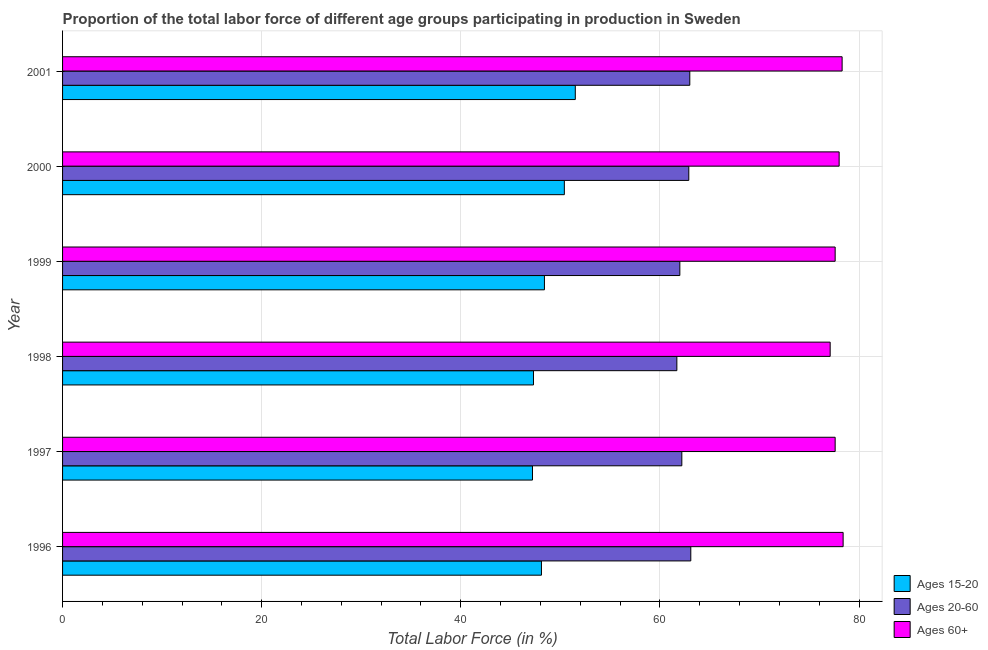How many different coloured bars are there?
Make the answer very short. 3. How many bars are there on the 3rd tick from the bottom?
Ensure brevity in your answer.  3. Across all years, what is the maximum percentage of labor force within the age group 15-20?
Your answer should be very brief. 51.5. Across all years, what is the minimum percentage of labor force above age 60?
Ensure brevity in your answer.  77.1. In which year was the percentage of labor force within the age group 20-60 maximum?
Offer a terse response. 1996. What is the total percentage of labor force within the age group 20-60 in the graph?
Keep it short and to the point. 374.9. What is the difference between the percentage of labor force above age 60 in 1997 and the percentage of labor force within the age group 15-20 in 1999?
Your response must be concise. 29.2. What is the average percentage of labor force within the age group 20-60 per year?
Give a very brief answer. 62.48. In the year 2000, what is the difference between the percentage of labor force above age 60 and percentage of labor force within the age group 15-20?
Your answer should be very brief. 27.6. What is the ratio of the percentage of labor force above age 60 in 1997 to that in 1999?
Make the answer very short. 1. Is the percentage of labor force within the age group 20-60 in 1999 less than that in 2001?
Give a very brief answer. Yes. Is the difference between the percentage of labor force within the age group 20-60 in 1998 and 1999 greater than the difference between the percentage of labor force within the age group 15-20 in 1998 and 1999?
Your response must be concise. Yes. What is the difference between the highest and the second highest percentage of labor force above age 60?
Provide a succinct answer. 0.1. What is the difference between the highest and the lowest percentage of labor force above age 60?
Your response must be concise. 1.3. What does the 3rd bar from the top in 2000 represents?
Keep it short and to the point. Ages 15-20. What does the 1st bar from the bottom in 1998 represents?
Offer a terse response. Ages 15-20. Is it the case that in every year, the sum of the percentage of labor force within the age group 15-20 and percentage of labor force within the age group 20-60 is greater than the percentage of labor force above age 60?
Offer a terse response. Yes. Are all the bars in the graph horizontal?
Provide a succinct answer. Yes. Does the graph contain grids?
Give a very brief answer. Yes. What is the title of the graph?
Provide a succinct answer. Proportion of the total labor force of different age groups participating in production in Sweden. What is the label or title of the Y-axis?
Offer a very short reply. Year. What is the Total Labor Force (in %) in Ages 15-20 in 1996?
Your response must be concise. 48.1. What is the Total Labor Force (in %) in Ages 20-60 in 1996?
Provide a succinct answer. 63.1. What is the Total Labor Force (in %) of Ages 60+ in 1996?
Provide a short and direct response. 78.4. What is the Total Labor Force (in %) in Ages 15-20 in 1997?
Make the answer very short. 47.2. What is the Total Labor Force (in %) of Ages 20-60 in 1997?
Your answer should be very brief. 62.2. What is the Total Labor Force (in %) in Ages 60+ in 1997?
Ensure brevity in your answer.  77.6. What is the Total Labor Force (in %) of Ages 15-20 in 1998?
Make the answer very short. 47.3. What is the Total Labor Force (in %) in Ages 20-60 in 1998?
Your answer should be compact. 61.7. What is the Total Labor Force (in %) in Ages 60+ in 1998?
Keep it short and to the point. 77.1. What is the Total Labor Force (in %) of Ages 15-20 in 1999?
Offer a very short reply. 48.4. What is the Total Labor Force (in %) of Ages 20-60 in 1999?
Keep it short and to the point. 62. What is the Total Labor Force (in %) in Ages 60+ in 1999?
Offer a terse response. 77.6. What is the Total Labor Force (in %) of Ages 15-20 in 2000?
Keep it short and to the point. 50.4. What is the Total Labor Force (in %) in Ages 20-60 in 2000?
Your response must be concise. 62.9. What is the Total Labor Force (in %) in Ages 15-20 in 2001?
Provide a succinct answer. 51.5. What is the Total Labor Force (in %) in Ages 20-60 in 2001?
Offer a very short reply. 63. What is the Total Labor Force (in %) of Ages 60+ in 2001?
Provide a succinct answer. 78.3. Across all years, what is the maximum Total Labor Force (in %) in Ages 15-20?
Provide a short and direct response. 51.5. Across all years, what is the maximum Total Labor Force (in %) of Ages 20-60?
Your answer should be very brief. 63.1. Across all years, what is the maximum Total Labor Force (in %) of Ages 60+?
Provide a short and direct response. 78.4. Across all years, what is the minimum Total Labor Force (in %) in Ages 15-20?
Provide a succinct answer. 47.2. Across all years, what is the minimum Total Labor Force (in %) of Ages 20-60?
Provide a short and direct response. 61.7. Across all years, what is the minimum Total Labor Force (in %) of Ages 60+?
Offer a very short reply. 77.1. What is the total Total Labor Force (in %) of Ages 15-20 in the graph?
Provide a short and direct response. 292.9. What is the total Total Labor Force (in %) in Ages 20-60 in the graph?
Provide a short and direct response. 374.9. What is the total Total Labor Force (in %) of Ages 60+ in the graph?
Provide a succinct answer. 467. What is the difference between the Total Labor Force (in %) in Ages 15-20 in 1996 and that in 1999?
Your response must be concise. -0.3. What is the difference between the Total Labor Force (in %) in Ages 20-60 in 1996 and that in 1999?
Give a very brief answer. 1.1. What is the difference between the Total Labor Force (in %) of Ages 15-20 in 1996 and that in 2001?
Keep it short and to the point. -3.4. What is the difference between the Total Labor Force (in %) of Ages 20-60 in 1996 and that in 2001?
Your answer should be compact. 0.1. What is the difference between the Total Labor Force (in %) of Ages 20-60 in 1997 and that in 1998?
Offer a terse response. 0.5. What is the difference between the Total Labor Force (in %) of Ages 20-60 in 1997 and that in 2000?
Give a very brief answer. -0.7. What is the difference between the Total Labor Force (in %) of Ages 15-20 in 1997 and that in 2001?
Give a very brief answer. -4.3. What is the difference between the Total Labor Force (in %) of Ages 20-60 in 1997 and that in 2001?
Provide a succinct answer. -0.8. What is the difference between the Total Labor Force (in %) of Ages 15-20 in 1998 and that in 1999?
Keep it short and to the point. -1.1. What is the difference between the Total Labor Force (in %) in Ages 20-60 in 1998 and that in 1999?
Ensure brevity in your answer.  -0.3. What is the difference between the Total Labor Force (in %) in Ages 60+ in 1998 and that in 1999?
Make the answer very short. -0.5. What is the difference between the Total Labor Force (in %) of Ages 15-20 in 1998 and that in 2000?
Provide a short and direct response. -3.1. What is the difference between the Total Labor Force (in %) in Ages 20-60 in 1998 and that in 2001?
Your response must be concise. -1.3. What is the difference between the Total Labor Force (in %) of Ages 60+ in 1998 and that in 2001?
Provide a succinct answer. -1.2. What is the difference between the Total Labor Force (in %) of Ages 15-20 in 1999 and that in 2000?
Your response must be concise. -2. What is the difference between the Total Labor Force (in %) in Ages 20-60 in 1999 and that in 2000?
Make the answer very short. -0.9. What is the difference between the Total Labor Force (in %) of Ages 60+ in 1999 and that in 2000?
Provide a short and direct response. -0.4. What is the difference between the Total Labor Force (in %) of Ages 15-20 in 1999 and that in 2001?
Your response must be concise. -3.1. What is the difference between the Total Labor Force (in %) of Ages 20-60 in 1999 and that in 2001?
Ensure brevity in your answer.  -1. What is the difference between the Total Labor Force (in %) of Ages 20-60 in 2000 and that in 2001?
Provide a short and direct response. -0.1. What is the difference between the Total Labor Force (in %) in Ages 15-20 in 1996 and the Total Labor Force (in %) in Ages 20-60 in 1997?
Provide a short and direct response. -14.1. What is the difference between the Total Labor Force (in %) in Ages 15-20 in 1996 and the Total Labor Force (in %) in Ages 60+ in 1997?
Provide a succinct answer. -29.5. What is the difference between the Total Labor Force (in %) in Ages 15-20 in 1996 and the Total Labor Force (in %) in Ages 60+ in 1998?
Ensure brevity in your answer.  -29. What is the difference between the Total Labor Force (in %) of Ages 15-20 in 1996 and the Total Labor Force (in %) of Ages 20-60 in 1999?
Offer a very short reply. -13.9. What is the difference between the Total Labor Force (in %) of Ages 15-20 in 1996 and the Total Labor Force (in %) of Ages 60+ in 1999?
Offer a terse response. -29.5. What is the difference between the Total Labor Force (in %) of Ages 15-20 in 1996 and the Total Labor Force (in %) of Ages 20-60 in 2000?
Give a very brief answer. -14.8. What is the difference between the Total Labor Force (in %) of Ages 15-20 in 1996 and the Total Labor Force (in %) of Ages 60+ in 2000?
Your answer should be very brief. -29.9. What is the difference between the Total Labor Force (in %) of Ages 20-60 in 1996 and the Total Labor Force (in %) of Ages 60+ in 2000?
Make the answer very short. -14.9. What is the difference between the Total Labor Force (in %) in Ages 15-20 in 1996 and the Total Labor Force (in %) in Ages 20-60 in 2001?
Your answer should be compact. -14.9. What is the difference between the Total Labor Force (in %) of Ages 15-20 in 1996 and the Total Labor Force (in %) of Ages 60+ in 2001?
Your answer should be very brief. -30.2. What is the difference between the Total Labor Force (in %) in Ages 20-60 in 1996 and the Total Labor Force (in %) in Ages 60+ in 2001?
Offer a terse response. -15.2. What is the difference between the Total Labor Force (in %) of Ages 15-20 in 1997 and the Total Labor Force (in %) of Ages 20-60 in 1998?
Your answer should be compact. -14.5. What is the difference between the Total Labor Force (in %) in Ages 15-20 in 1997 and the Total Labor Force (in %) in Ages 60+ in 1998?
Your answer should be very brief. -29.9. What is the difference between the Total Labor Force (in %) in Ages 20-60 in 1997 and the Total Labor Force (in %) in Ages 60+ in 1998?
Your response must be concise. -14.9. What is the difference between the Total Labor Force (in %) of Ages 15-20 in 1997 and the Total Labor Force (in %) of Ages 20-60 in 1999?
Make the answer very short. -14.8. What is the difference between the Total Labor Force (in %) in Ages 15-20 in 1997 and the Total Labor Force (in %) in Ages 60+ in 1999?
Provide a succinct answer. -30.4. What is the difference between the Total Labor Force (in %) in Ages 20-60 in 1997 and the Total Labor Force (in %) in Ages 60+ in 1999?
Offer a very short reply. -15.4. What is the difference between the Total Labor Force (in %) in Ages 15-20 in 1997 and the Total Labor Force (in %) in Ages 20-60 in 2000?
Your answer should be very brief. -15.7. What is the difference between the Total Labor Force (in %) in Ages 15-20 in 1997 and the Total Labor Force (in %) in Ages 60+ in 2000?
Provide a short and direct response. -30.8. What is the difference between the Total Labor Force (in %) in Ages 20-60 in 1997 and the Total Labor Force (in %) in Ages 60+ in 2000?
Offer a terse response. -15.8. What is the difference between the Total Labor Force (in %) of Ages 15-20 in 1997 and the Total Labor Force (in %) of Ages 20-60 in 2001?
Offer a terse response. -15.8. What is the difference between the Total Labor Force (in %) in Ages 15-20 in 1997 and the Total Labor Force (in %) in Ages 60+ in 2001?
Keep it short and to the point. -31.1. What is the difference between the Total Labor Force (in %) in Ages 20-60 in 1997 and the Total Labor Force (in %) in Ages 60+ in 2001?
Your answer should be very brief. -16.1. What is the difference between the Total Labor Force (in %) in Ages 15-20 in 1998 and the Total Labor Force (in %) in Ages 20-60 in 1999?
Give a very brief answer. -14.7. What is the difference between the Total Labor Force (in %) in Ages 15-20 in 1998 and the Total Labor Force (in %) in Ages 60+ in 1999?
Offer a terse response. -30.3. What is the difference between the Total Labor Force (in %) of Ages 20-60 in 1998 and the Total Labor Force (in %) of Ages 60+ in 1999?
Keep it short and to the point. -15.9. What is the difference between the Total Labor Force (in %) of Ages 15-20 in 1998 and the Total Labor Force (in %) of Ages 20-60 in 2000?
Ensure brevity in your answer.  -15.6. What is the difference between the Total Labor Force (in %) of Ages 15-20 in 1998 and the Total Labor Force (in %) of Ages 60+ in 2000?
Your response must be concise. -30.7. What is the difference between the Total Labor Force (in %) of Ages 20-60 in 1998 and the Total Labor Force (in %) of Ages 60+ in 2000?
Your answer should be very brief. -16.3. What is the difference between the Total Labor Force (in %) of Ages 15-20 in 1998 and the Total Labor Force (in %) of Ages 20-60 in 2001?
Your answer should be compact. -15.7. What is the difference between the Total Labor Force (in %) in Ages 15-20 in 1998 and the Total Labor Force (in %) in Ages 60+ in 2001?
Make the answer very short. -31. What is the difference between the Total Labor Force (in %) in Ages 20-60 in 1998 and the Total Labor Force (in %) in Ages 60+ in 2001?
Make the answer very short. -16.6. What is the difference between the Total Labor Force (in %) of Ages 15-20 in 1999 and the Total Labor Force (in %) of Ages 20-60 in 2000?
Give a very brief answer. -14.5. What is the difference between the Total Labor Force (in %) of Ages 15-20 in 1999 and the Total Labor Force (in %) of Ages 60+ in 2000?
Your answer should be compact. -29.6. What is the difference between the Total Labor Force (in %) in Ages 20-60 in 1999 and the Total Labor Force (in %) in Ages 60+ in 2000?
Provide a succinct answer. -16. What is the difference between the Total Labor Force (in %) of Ages 15-20 in 1999 and the Total Labor Force (in %) of Ages 20-60 in 2001?
Your response must be concise. -14.6. What is the difference between the Total Labor Force (in %) of Ages 15-20 in 1999 and the Total Labor Force (in %) of Ages 60+ in 2001?
Provide a short and direct response. -29.9. What is the difference between the Total Labor Force (in %) of Ages 20-60 in 1999 and the Total Labor Force (in %) of Ages 60+ in 2001?
Make the answer very short. -16.3. What is the difference between the Total Labor Force (in %) of Ages 15-20 in 2000 and the Total Labor Force (in %) of Ages 60+ in 2001?
Offer a terse response. -27.9. What is the difference between the Total Labor Force (in %) in Ages 20-60 in 2000 and the Total Labor Force (in %) in Ages 60+ in 2001?
Offer a very short reply. -15.4. What is the average Total Labor Force (in %) of Ages 15-20 per year?
Your answer should be very brief. 48.82. What is the average Total Labor Force (in %) in Ages 20-60 per year?
Your answer should be compact. 62.48. What is the average Total Labor Force (in %) of Ages 60+ per year?
Your response must be concise. 77.83. In the year 1996, what is the difference between the Total Labor Force (in %) in Ages 15-20 and Total Labor Force (in %) in Ages 60+?
Provide a succinct answer. -30.3. In the year 1996, what is the difference between the Total Labor Force (in %) in Ages 20-60 and Total Labor Force (in %) in Ages 60+?
Make the answer very short. -15.3. In the year 1997, what is the difference between the Total Labor Force (in %) of Ages 15-20 and Total Labor Force (in %) of Ages 20-60?
Provide a short and direct response. -15. In the year 1997, what is the difference between the Total Labor Force (in %) in Ages 15-20 and Total Labor Force (in %) in Ages 60+?
Provide a succinct answer. -30.4. In the year 1997, what is the difference between the Total Labor Force (in %) of Ages 20-60 and Total Labor Force (in %) of Ages 60+?
Make the answer very short. -15.4. In the year 1998, what is the difference between the Total Labor Force (in %) in Ages 15-20 and Total Labor Force (in %) in Ages 20-60?
Keep it short and to the point. -14.4. In the year 1998, what is the difference between the Total Labor Force (in %) in Ages 15-20 and Total Labor Force (in %) in Ages 60+?
Your answer should be compact. -29.8. In the year 1998, what is the difference between the Total Labor Force (in %) of Ages 20-60 and Total Labor Force (in %) of Ages 60+?
Ensure brevity in your answer.  -15.4. In the year 1999, what is the difference between the Total Labor Force (in %) of Ages 15-20 and Total Labor Force (in %) of Ages 20-60?
Ensure brevity in your answer.  -13.6. In the year 1999, what is the difference between the Total Labor Force (in %) in Ages 15-20 and Total Labor Force (in %) in Ages 60+?
Your answer should be very brief. -29.2. In the year 1999, what is the difference between the Total Labor Force (in %) in Ages 20-60 and Total Labor Force (in %) in Ages 60+?
Your response must be concise. -15.6. In the year 2000, what is the difference between the Total Labor Force (in %) in Ages 15-20 and Total Labor Force (in %) in Ages 60+?
Your answer should be compact. -27.6. In the year 2000, what is the difference between the Total Labor Force (in %) in Ages 20-60 and Total Labor Force (in %) in Ages 60+?
Your answer should be very brief. -15.1. In the year 2001, what is the difference between the Total Labor Force (in %) in Ages 15-20 and Total Labor Force (in %) in Ages 20-60?
Offer a very short reply. -11.5. In the year 2001, what is the difference between the Total Labor Force (in %) in Ages 15-20 and Total Labor Force (in %) in Ages 60+?
Make the answer very short. -26.8. In the year 2001, what is the difference between the Total Labor Force (in %) in Ages 20-60 and Total Labor Force (in %) in Ages 60+?
Your response must be concise. -15.3. What is the ratio of the Total Labor Force (in %) in Ages 15-20 in 1996 to that in 1997?
Give a very brief answer. 1.02. What is the ratio of the Total Labor Force (in %) in Ages 20-60 in 1996 to that in 1997?
Give a very brief answer. 1.01. What is the ratio of the Total Labor Force (in %) of Ages 60+ in 1996 to that in 1997?
Give a very brief answer. 1.01. What is the ratio of the Total Labor Force (in %) of Ages 15-20 in 1996 to that in 1998?
Keep it short and to the point. 1.02. What is the ratio of the Total Labor Force (in %) in Ages 20-60 in 1996 to that in 1998?
Give a very brief answer. 1.02. What is the ratio of the Total Labor Force (in %) in Ages 60+ in 1996 to that in 1998?
Offer a terse response. 1.02. What is the ratio of the Total Labor Force (in %) of Ages 15-20 in 1996 to that in 1999?
Your answer should be very brief. 0.99. What is the ratio of the Total Labor Force (in %) in Ages 20-60 in 1996 to that in 1999?
Your response must be concise. 1.02. What is the ratio of the Total Labor Force (in %) of Ages 60+ in 1996 to that in 1999?
Offer a very short reply. 1.01. What is the ratio of the Total Labor Force (in %) in Ages 15-20 in 1996 to that in 2000?
Keep it short and to the point. 0.95. What is the ratio of the Total Labor Force (in %) in Ages 60+ in 1996 to that in 2000?
Your response must be concise. 1.01. What is the ratio of the Total Labor Force (in %) of Ages 15-20 in 1996 to that in 2001?
Keep it short and to the point. 0.93. What is the ratio of the Total Labor Force (in %) in Ages 20-60 in 1996 to that in 2001?
Make the answer very short. 1. What is the ratio of the Total Labor Force (in %) of Ages 15-20 in 1997 to that in 1998?
Keep it short and to the point. 1. What is the ratio of the Total Labor Force (in %) of Ages 60+ in 1997 to that in 1998?
Offer a terse response. 1.01. What is the ratio of the Total Labor Force (in %) of Ages 15-20 in 1997 to that in 1999?
Provide a short and direct response. 0.98. What is the ratio of the Total Labor Force (in %) in Ages 20-60 in 1997 to that in 1999?
Offer a terse response. 1. What is the ratio of the Total Labor Force (in %) in Ages 60+ in 1997 to that in 1999?
Your answer should be very brief. 1. What is the ratio of the Total Labor Force (in %) in Ages 15-20 in 1997 to that in 2000?
Provide a succinct answer. 0.94. What is the ratio of the Total Labor Force (in %) of Ages 20-60 in 1997 to that in 2000?
Make the answer very short. 0.99. What is the ratio of the Total Labor Force (in %) of Ages 15-20 in 1997 to that in 2001?
Offer a terse response. 0.92. What is the ratio of the Total Labor Force (in %) of Ages 20-60 in 1997 to that in 2001?
Your response must be concise. 0.99. What is the ratio of the Total Labor Force (in %) in Ages 60+ in 1997 to that in 2001?
Your answer should be very brief. 0.99. What is the ratio of the Total Labor Force (in %) of Ages 15-20 in 1998 to that in 1999?
Make the answer very short. 0.98. What is the ratio of the Total Labor Force (in %) of Ages 15-20 in 1998 to that in 2000?
Your answer should be very brief. 0.94. What is the ratio of the Total Labor Force (in %) in Ages 20-60 in 1998 to that in 2000?
Offer a very short reply. 0.98. What is the ratio of the Total Labor Force (in %) of Ages 15-20 in 1998 to that in 2001?
Give a very brief answer. 0.92. What is the ratio of the Total Labor Force (in %) in Ages 20-60 in 1998 to that in 2001?
Keep it short and to the point. 0.98. What is the ratio of the Total Labor Force (in %) in Ages 60+ in 1998 to that in 2001?
Your answer should be very brief. 0.98. What is the ratio of the Total Labor Force (in %) in Ages 15-20 in 1999 to that in 2000?
Offer a terse response. 0.96. What is the ratio of the Total Labor Force (in %) in Ages 20-60 in 1999 to that in 2000?
Your answer should be compact. 0.99. What is the ratio of the Total Labor Force (in %) of Ages 60+ in 1999 to that in 2000?
Provide a succinct answer. 0.99. What is the ratio of the Total Labor Force (in %) of Ages 15-20 in 1999 to that in 2001?
Offer a very short reply. 0.94. What is the ratio of the Total Labor Force (in %) in Ages 20-60 in 1999 to that in 2001?
Your answer should be compact. 0.98. What is the ratio of the Total Labor Force (in %) of Ages 15-20 in 2000 to that in 2001?
Provide a short and direct response. 0.98. What is the difference between the highest and the second highest Total Labor Force (in %) of Ages 15-20?
Offer a terse response. 1.1. What is the difference between the highest and the second highest Total Labor Force (in %) of Ages 60+?
Make the answer very short. 0.1. What is the difference between the highest and the lowest Total Labor Force (in %) in Ages 15-20?
Ensure brevity in your answer.  4.3. 